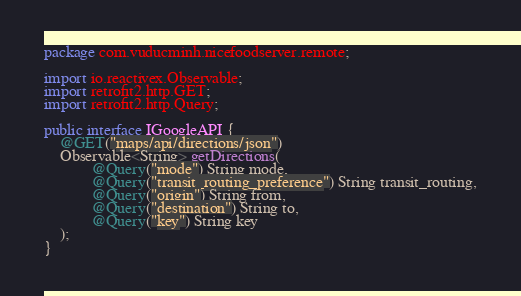<code> <loc_0><loc_0><loc_500><loc_500><_Java_>package com.vuducminh.nicefoodserver.remote;

import io.reactivex.Observable;
import retrofit2.http.GET;
import retrofit2.http.Query;

public interface IGoogleAPI {
    @GET("maps/api/directions/json")
    Observable<String> getDirections(
            @Query("mode") String mode,
            @Query("transit_routing_preference") String transit_routing,
            @Query("origin") String from,
            @Query("destination") String to,
            @Query("key") String key
    );
}
</code> 